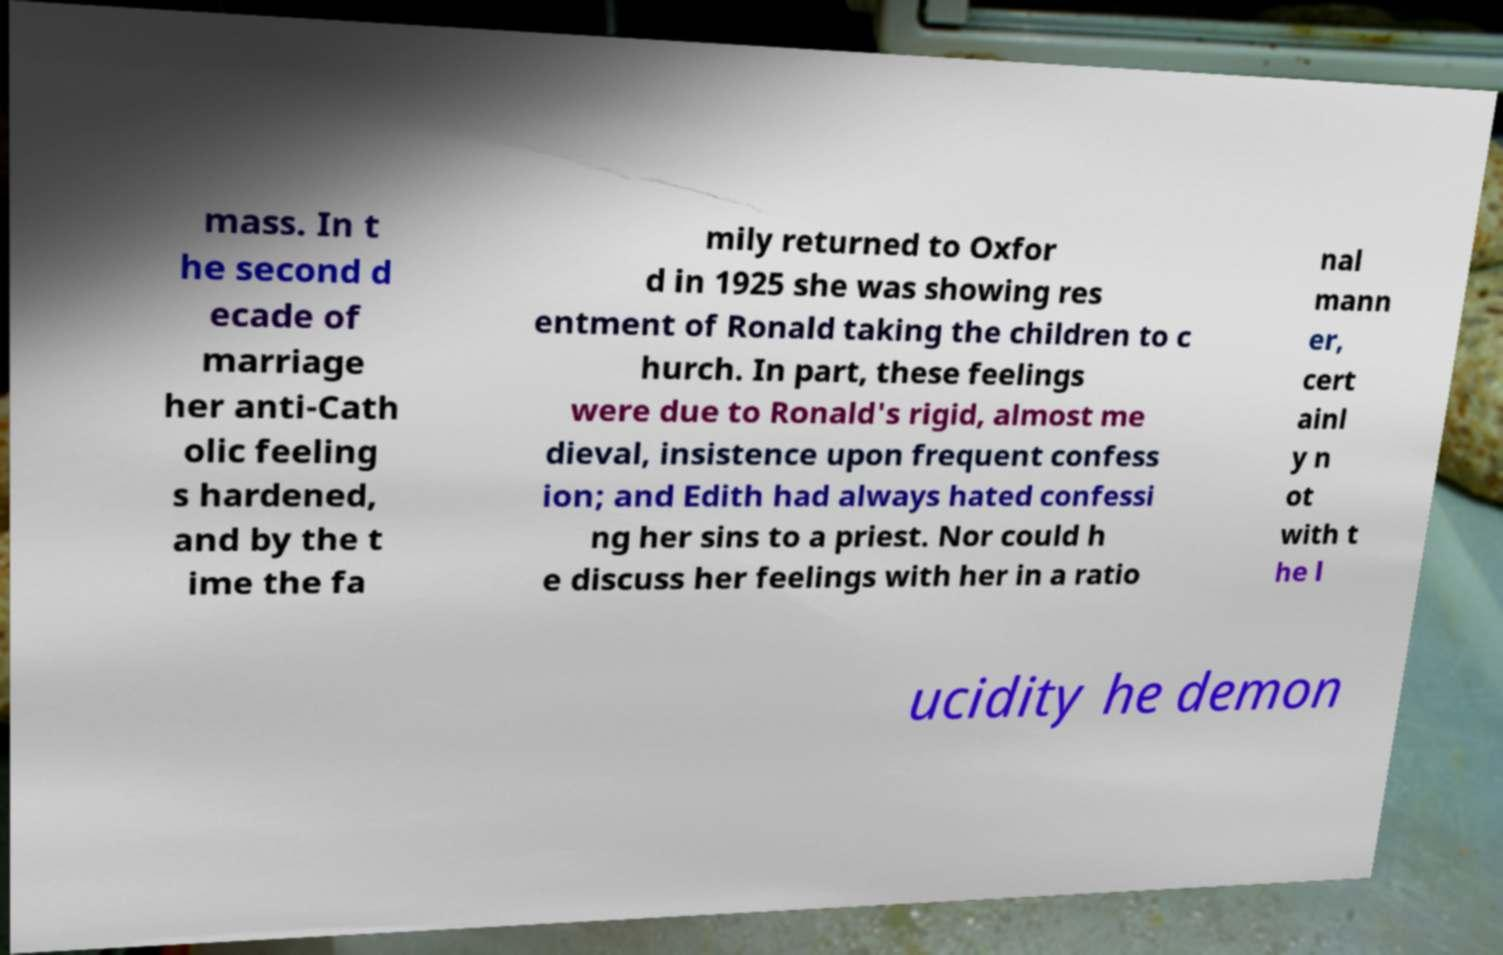Can you read and provide the text displayed in the image?This photo seems to have some interesting text. Can you extract and type it out for me? mass. In t he second d ecade of marriage her anti-Cath olic feeling s hardened, and by the t ime the fa mily returned to Oxfor d in 1925 she was showing res entment of Ronald taking the children to c hurch. In part, these feelings were due to Ronald's rigid, almost me dieval, insistence upon frequent confess ion; and Edith had always hated confessi ng her sins to a priest. Nor could h e discuss her feelings with her in a ratio nal mann er, cert ainl y n ot with t he l ucidity he demon 